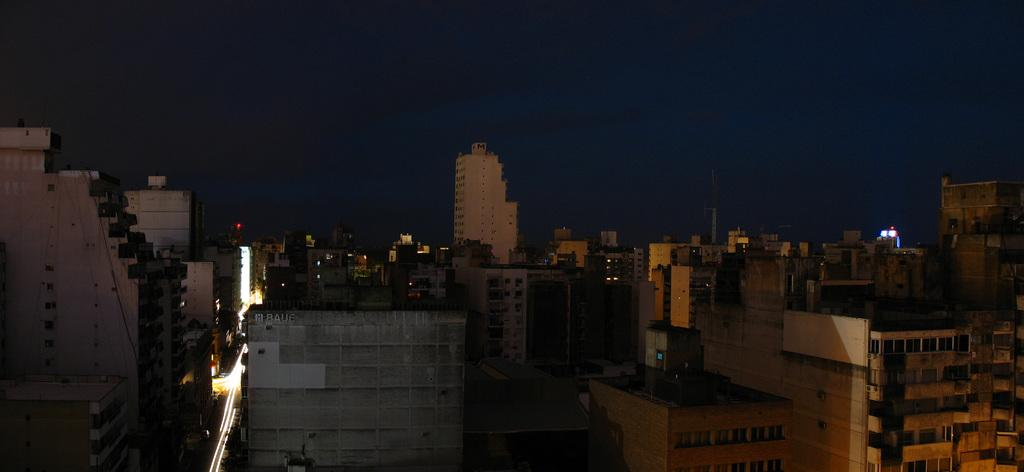What type of structures are present in the image? There are buildings in the image. What feature do the buildings have? The buildings have windows. What else can be seen in the image besides the buildings? There is a road in the image. What is present on the road? There are lights on the road. What other object can be seen in the image? There is a metal tower in the image. What can be observed about the sky in the image? The sky is dark in the background of the image. What type of soda is being advertised on the list in the image? There is no list or soda present in the image. What knowledge can be gained from the image about the history of the buildings? The image does not provide any information about the history of the buildings. 